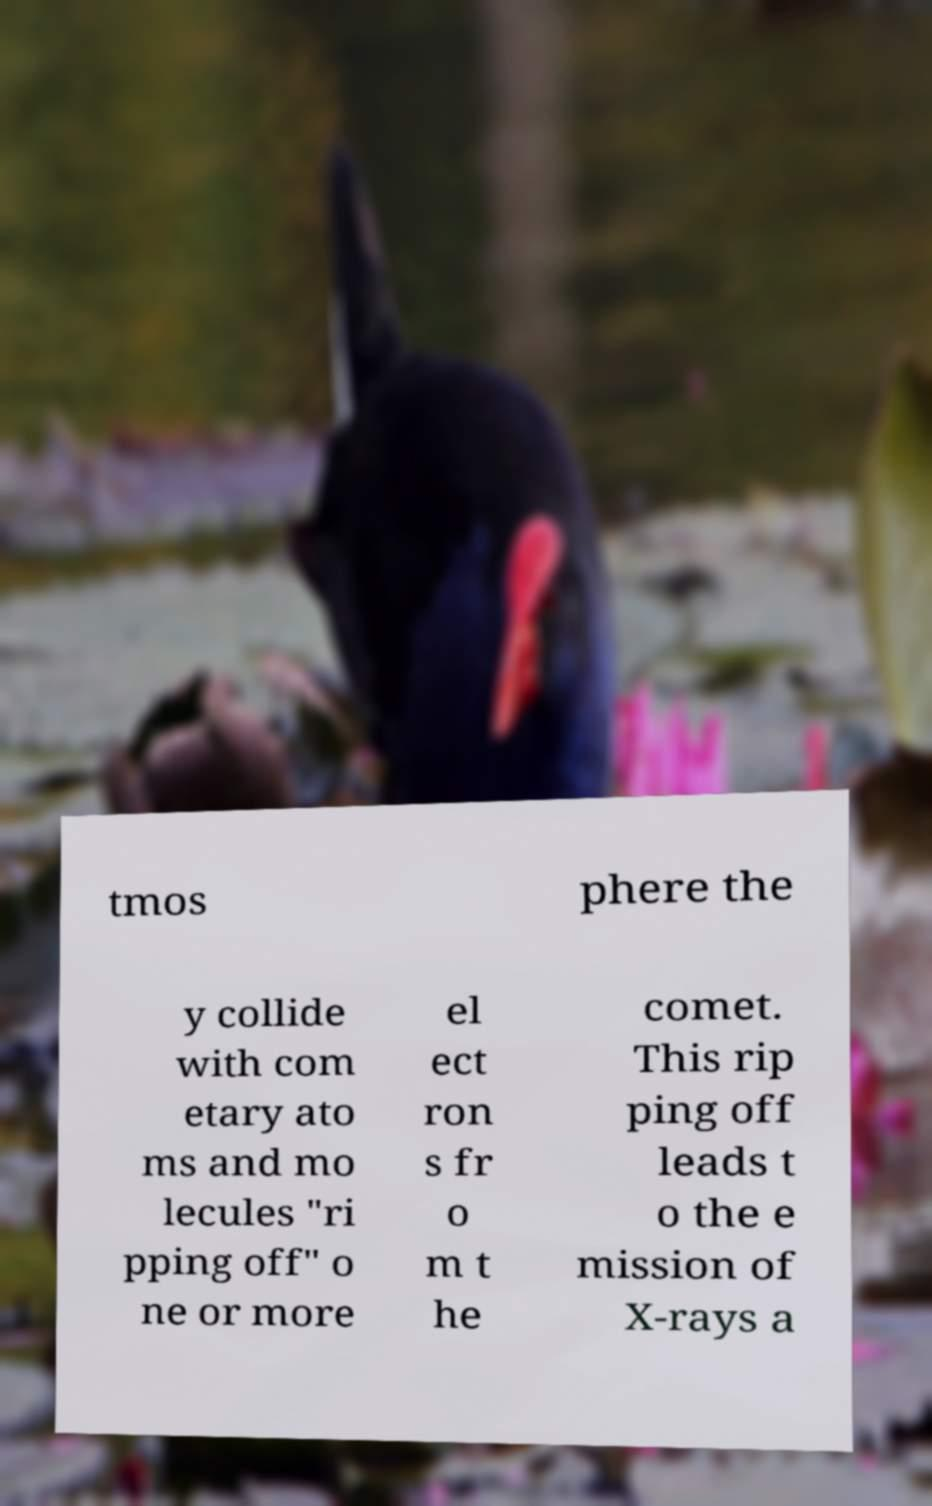I need the written content from this picture converted into text. Can you do that? tmos phere the y collide with com etary ato ms and mo lecules "ri pping off" o ne or more el ect ron s fr o m t he comet. This rip ping off leads t o the e mission of X-rays a 